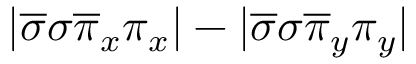Convert formula to latex. <formula><loc_0><loc_0><loc_500><loc_500>| \overline { \sigma } \sigma \overline { \pi } _ { x } \pi _ { x } | - | \overline { \sigma } \sigma \overline { \pi } _ { y } \pi _ { y } |</formula> 